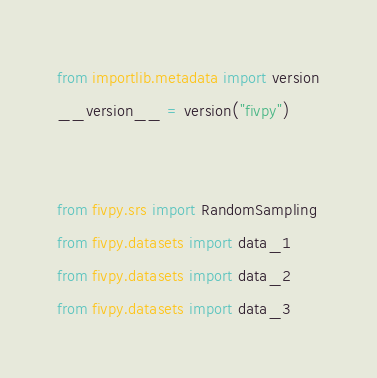<code> <loc_0><loc_0><loc_500><loc_500><_Python_>from importlib.metadata import version
__version__ = version("fivpy")


from fivpy.srs import RandomSampling
from fivpy.datasets import data_1
from fivpy.datasets import data_2
from fivpy.datasets import data_3</code> 